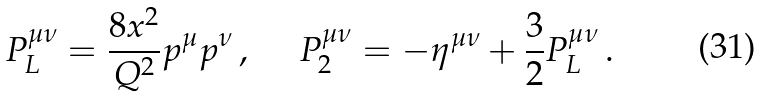<formula> <loc_0><loc_0><loc_500><loc_500>P _ { L } ^ { \mu \nu } = \frac { 8 x ^ { 2 } } { Q ^ { 2 } } p ^ { \mu } p ^ { \nu } \, , \quad \ P _ { 2 } ^ { \mu \nu } = - \eta ^ { \mu \nu } + \frac { 3 } { 2 } P ^ { \mu \nu } _ { L } \, .</formula> 